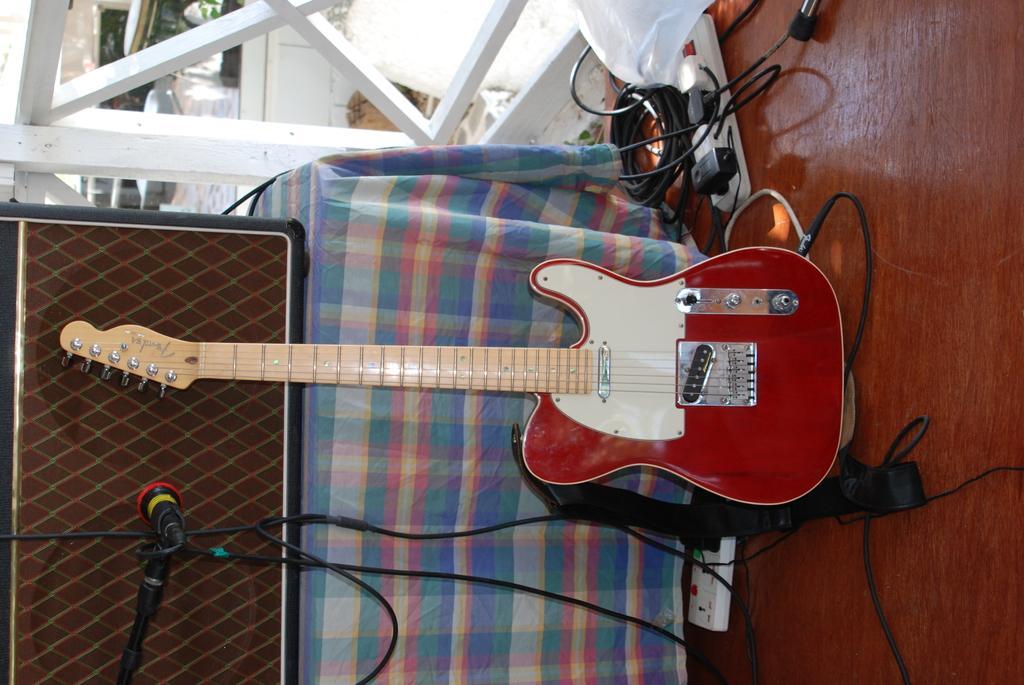In one or two sentences, can you explain what this image depicts? In this image there are objects truncated towards the top of the image, there is a guitar on the surface, there are wires, there are objects on the surface, there is a microphone, there is a stand truncated towards the bottom of the image, there is an object truncated towards the left of the image, there is a cloth truncated towards the bottom of the image, there is the wall. 